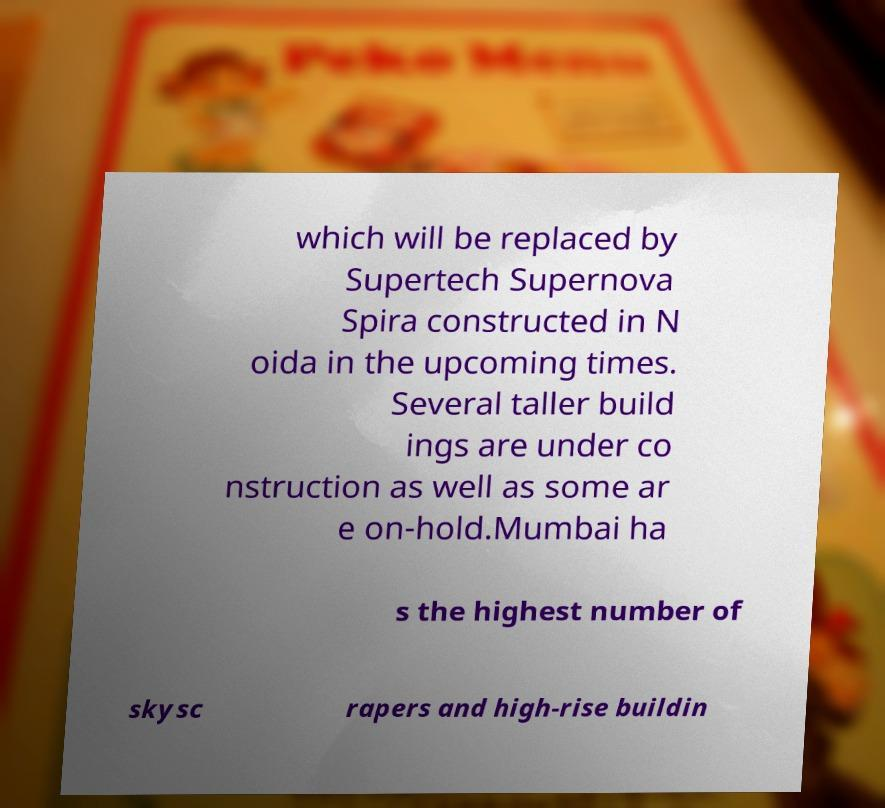Could you extract and type out the text from this image? which will be replaced by Supertech Supernova Spira constructed in N oida in the upcoming times. Several taller build ings are under co nstruction as well as some ar e on-hold.Mumbai ha s the highest number of skysc rapers and high-rise buildin 